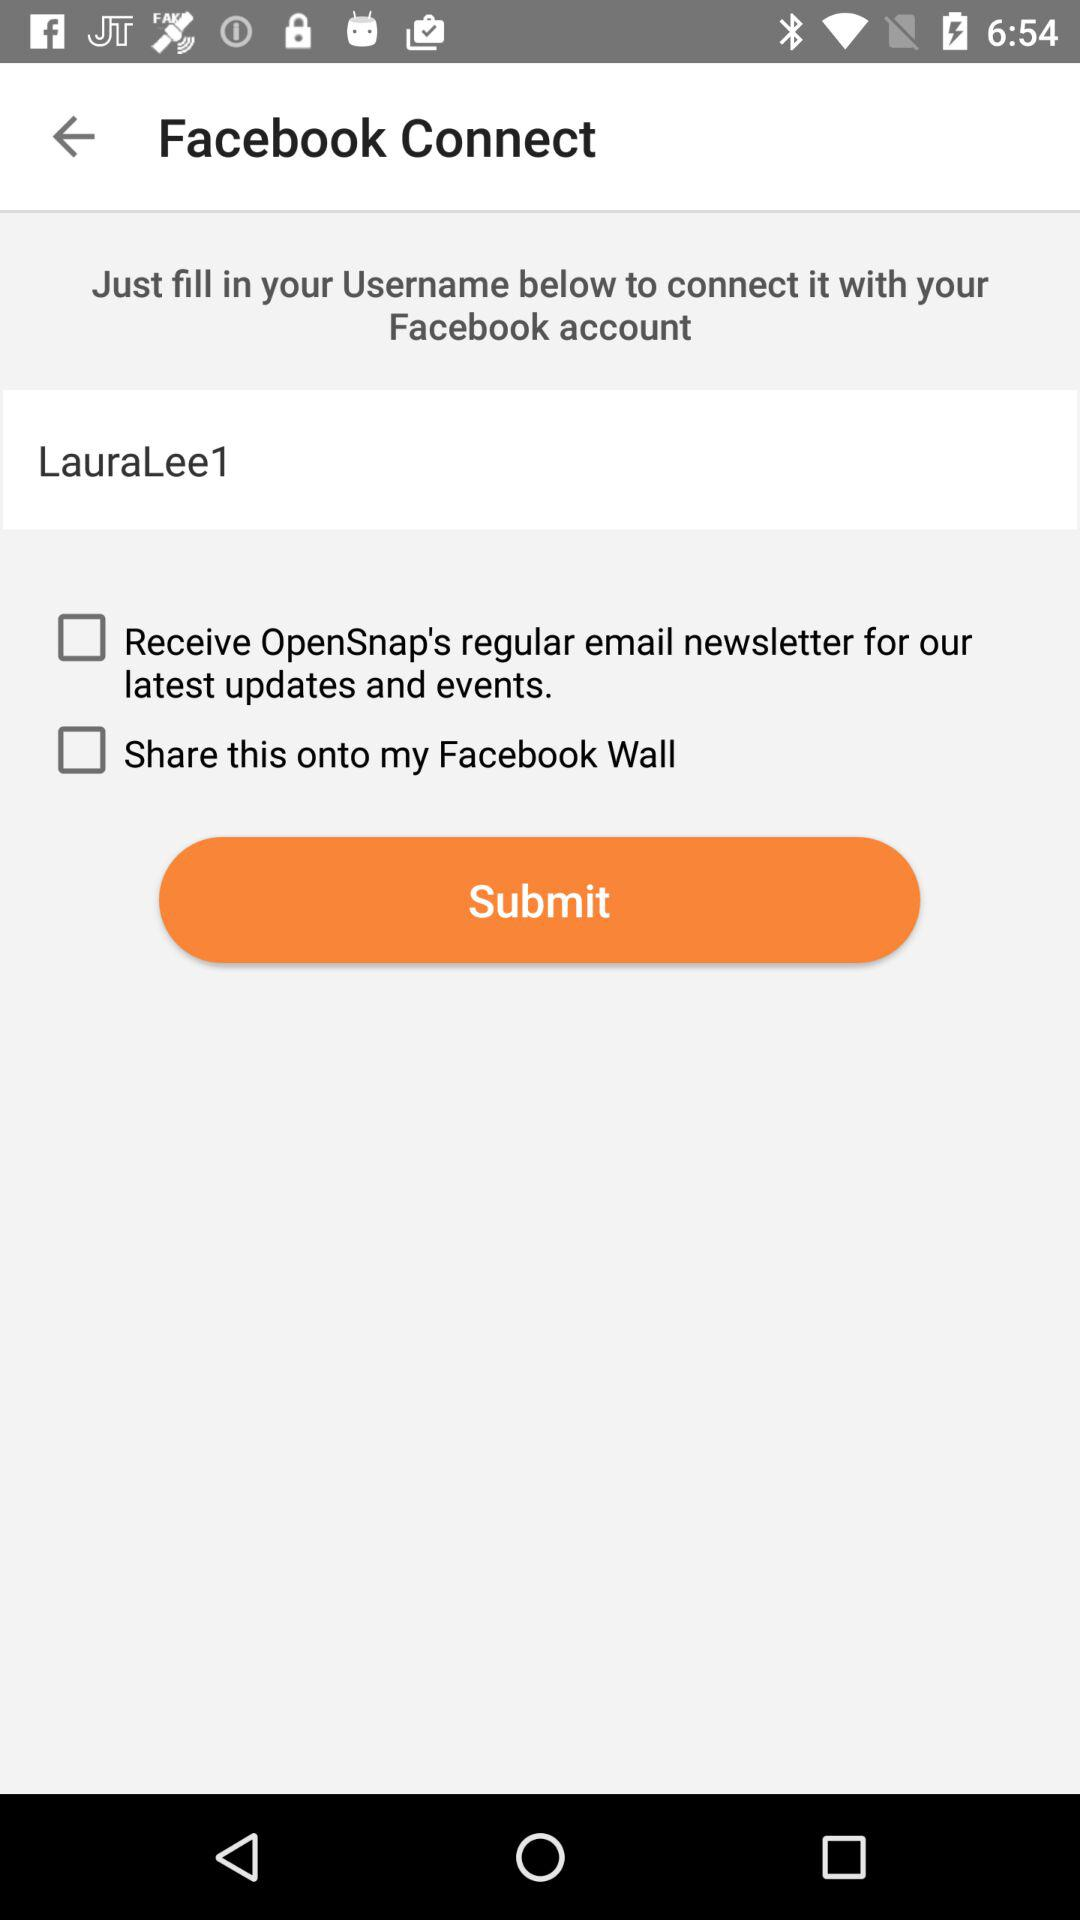What is the username? The username is "LauraLee1". 